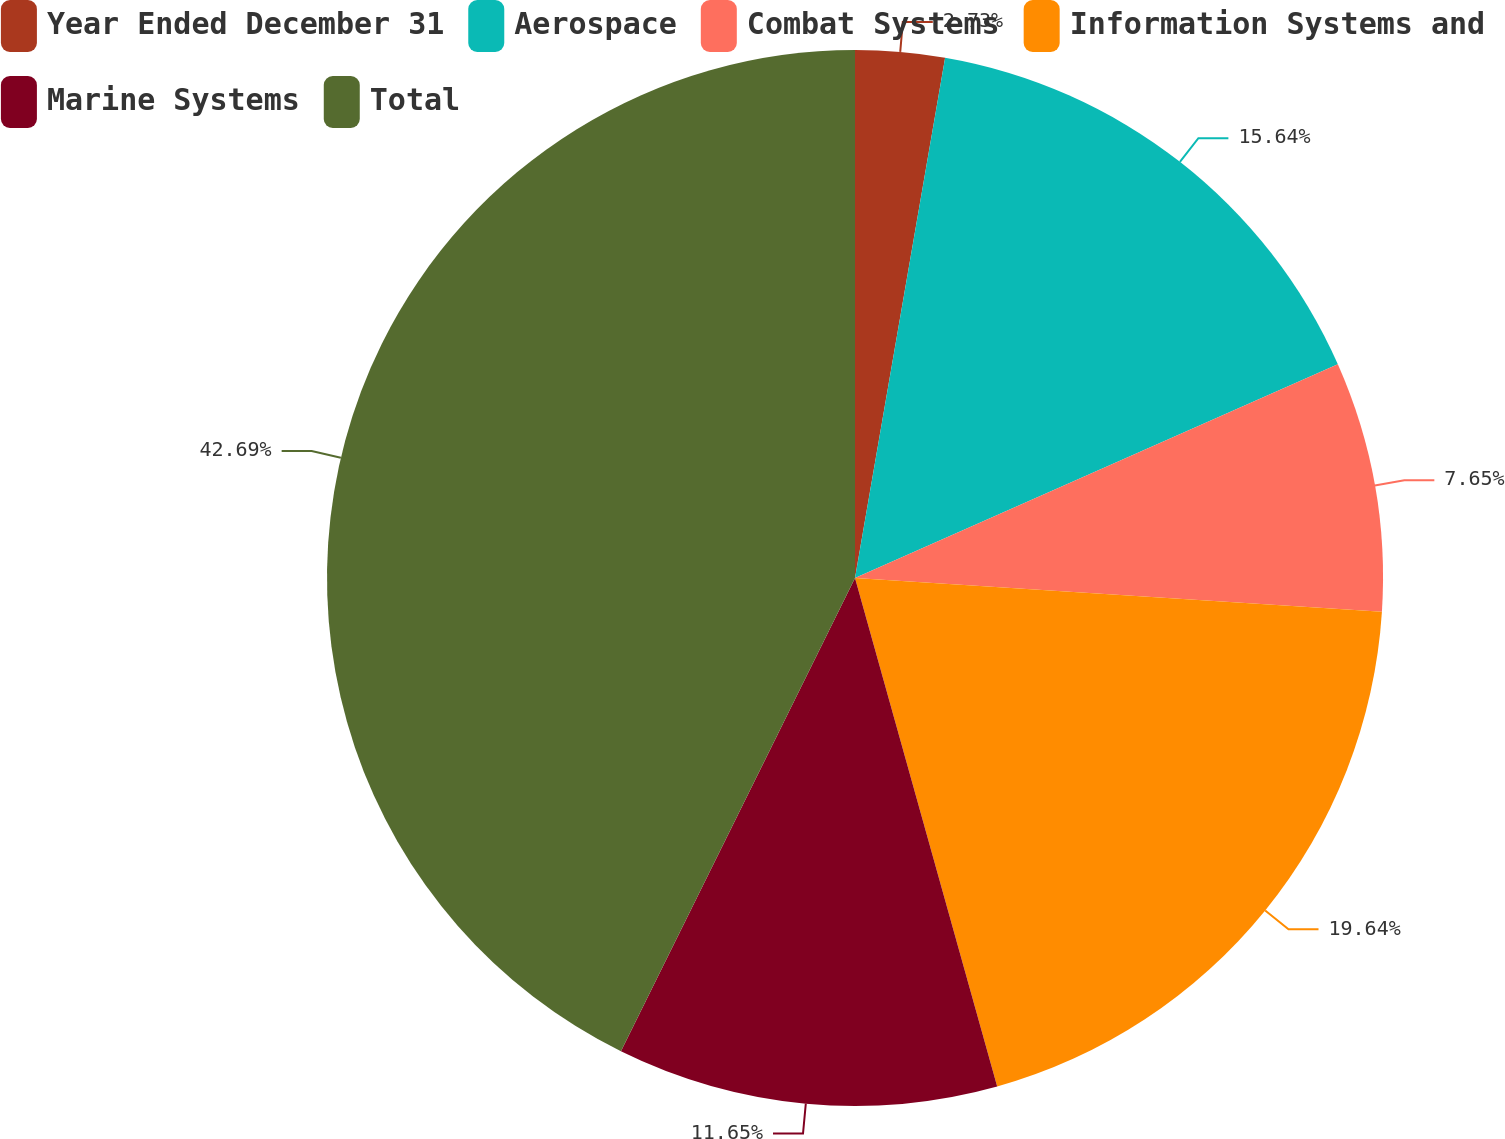Convert chart to OTSL. <chart><loc_0><loc_0><loc_500><loc_500><pie_chart><fcel>Year Ended December 31<fcel>Aerospace<fcel>Combat Systems<fcel>Information Systems and<fcel>Marine Systems<fcel>Total<nl><fcel>2.73%<fcel>15.64%<fcel>7.65%<fcel>19.64%<fcel>11.65%<fcel>42.69%<nl></chart> 